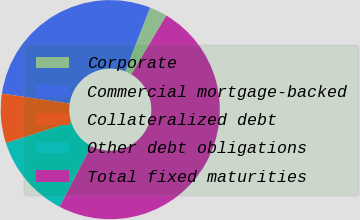Convert chart to OTSL. <chart><loc_0><loc_0><loc_500><loc_500><pie_chart><fcel>Corporate<fcel>Commercial mortgage-backed<fcel>Collateralized debt<fcel>Other debt obligations<fcel>Total fixed maturities<nl><fcel>2.64%<fcel>28.57%<fcel>7.29%<fcel>12.4%<fcel>49.1%<nl></chart> 